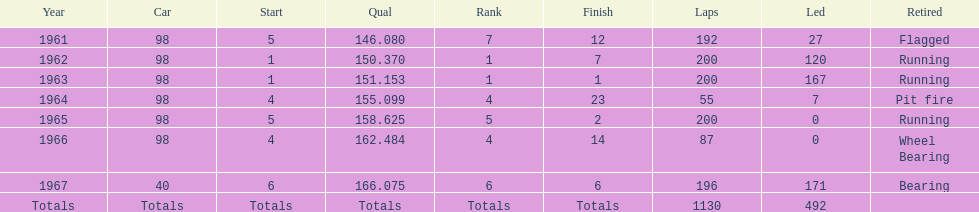Previous to 1965, when did jones have a number 5 start at the indy 500? 1961. 